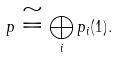<formula> <loc_0><loc_0><loc_500><loc_500>p \cong \bigoplus _ { i } p _ { i } ( 1 ) .</formula> 